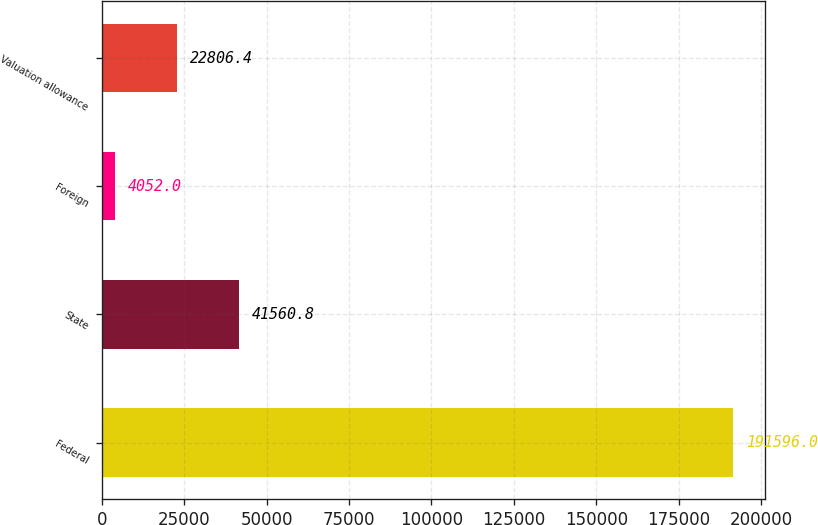<chart> <loc_0><loc_0><loc_500><loc_500><bar_chart><fcel>Federal<fcel>State<fcel>Foreign<fcel>Valuation allowance<nl><fcel>191596<fcel>41560.8<fcel>4052<fcel>22806.4<nl></chart> 